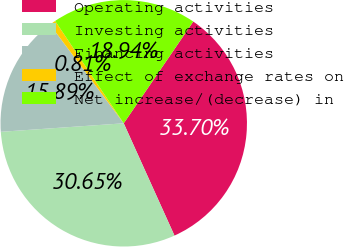Convert chart to OTSL. <chart><loc_0><loc_0><loc_500><loc_500><pie_chart><fcel>Operating activities<fcel>Investing activities<fcel>Financing activities<fcel>Effect of exchange rates on<fcel>Net increase/(decrease) in<nl><fcel>33.7%<fcel>30.65%<fcel>15.89%<fcel>0.81%<fcel>18.94%<nl></chart> 